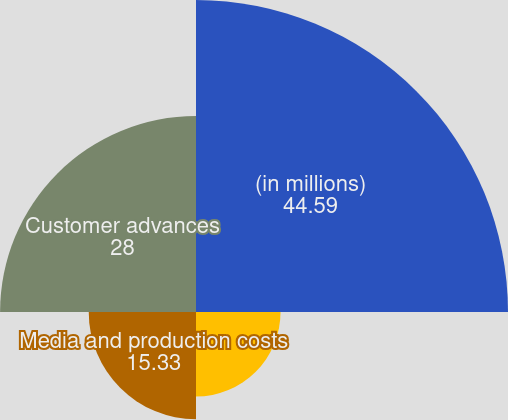Convert chart to OTSL. <chart><loc_0><loc_0><loc_500><loc_500><pie_chart><fcel>(in millions)<fcel>Contract assets and unbilled<fcel>Media and production costs<fcel>Customer advances<nl><fcel>44.59%<fcel>12.08%<fcel>15.33%<fcel>28.0%<nl></chart> 